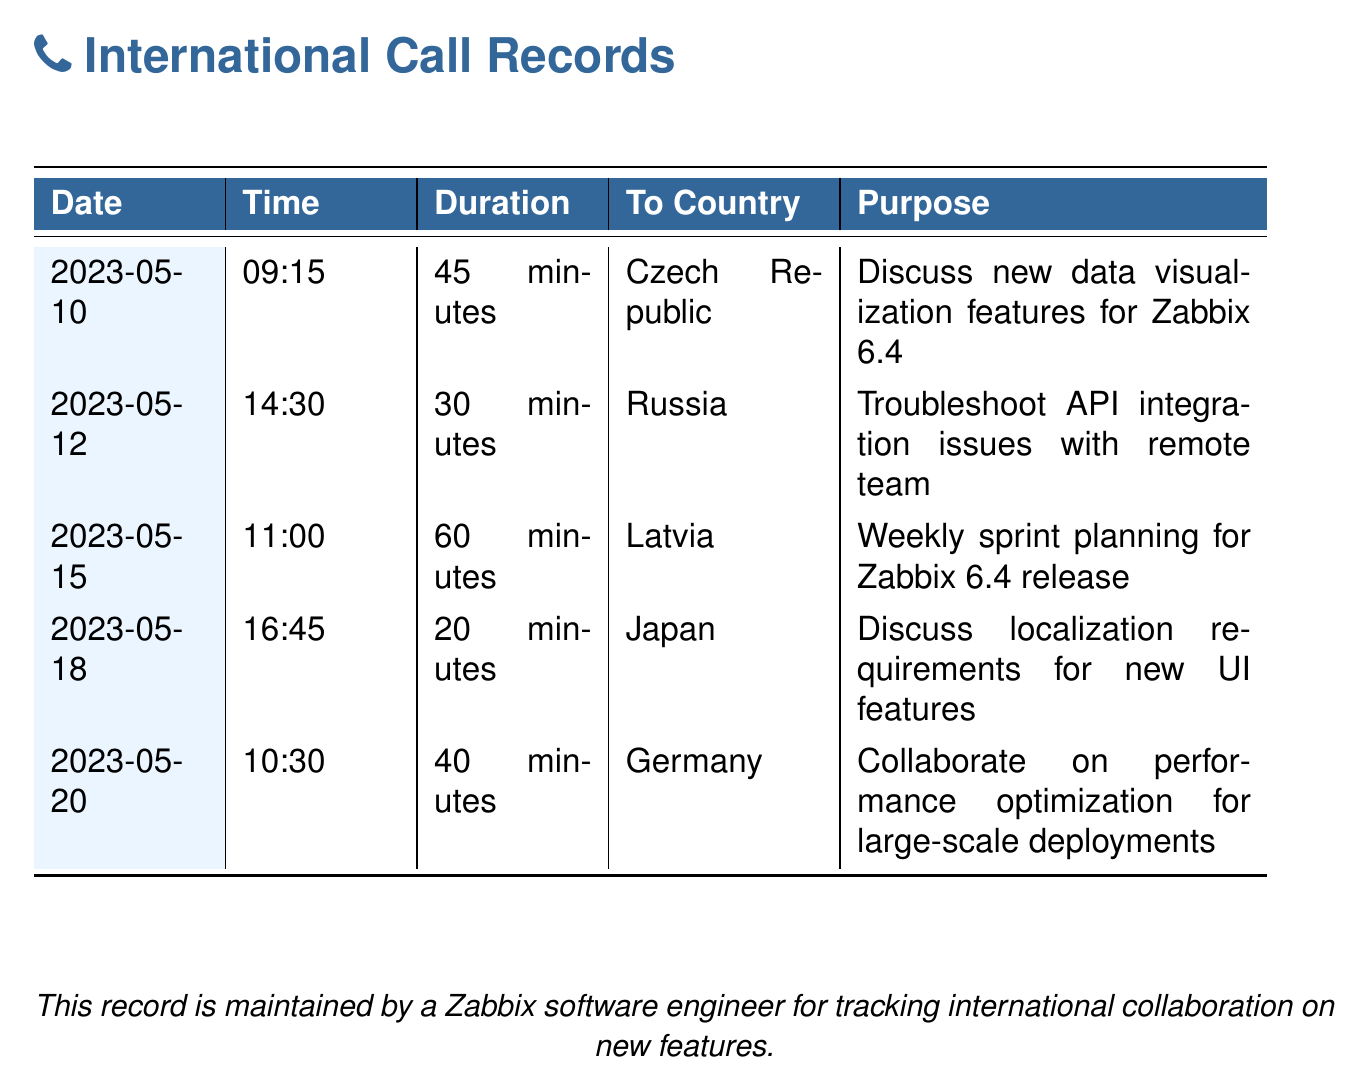What date was the call to the Czech Republic? The call to the Czech Republic was made on May 10, 2023.
Answer: May 10, 2023 How long did the call to Japan last? The duration of the call to Japan was recorded as 20 minutes.
Answer: 20 minutes What was discussed during the call to Russia? The purpose of the call to Russia was to troubleshoot API integration issues with the remote team.
Answer: Troubleshoot API integration issues Which country's call had the longest duration? The call to Latvia had the longest duration of 60 minutes.
Answer: Latvia How many calls were made in total? There are 5 entries listed, indicating a total of 5 calls made.
Answer: 5 On what date was the weekly sprint planning discussed? The weekly sprint planning for Zabbix 6.4 release took place on May 15, 2023.
Answer: May 15, 2023 What is the primary purpose of this document? The document is maintained for tracking international collaboration on new features.
Answer: Tracking international collaboration Which country was involved in discussing localization requirements? The discussion about localization requirements involved Japan.
Answer: Japan 